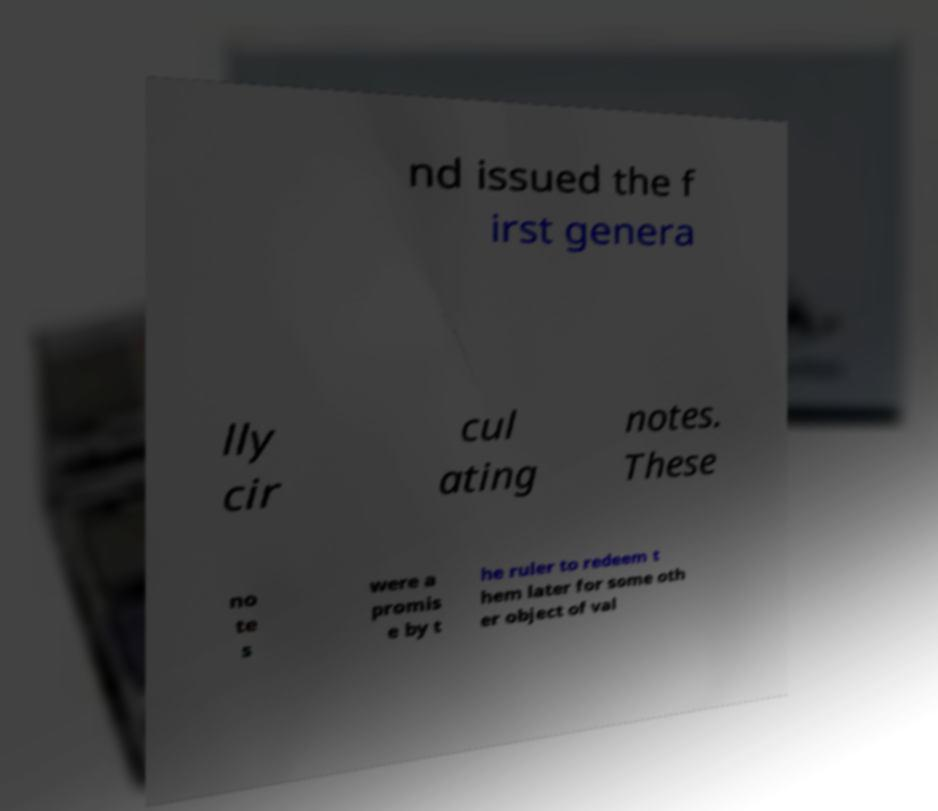For documentation purposes, I need the text within this image transcribed. Could you provide that? nd issued the f irst genera lly cir cul ating notes. These no te s were a promis e by t he ruler to redeem t hem later for some oth er object of val 